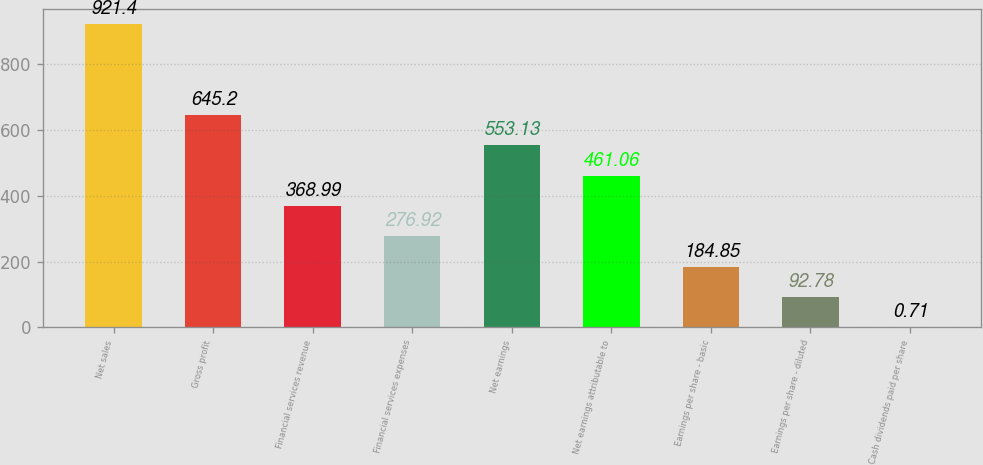Convert chart. <chart><loc_0><loc_0><loc_500><loc_500><bar_chart><fcel>Net sales<fcel>Gross profit<fcel>Financial services revenue<fcel>Financial services expenses<fcel>Net earnings<fcel>Net earnings attributable to<fcel>Earnings per share - basic<fcel>Earnings per share - diluted<fcel>Cash dividends paid per share<nl><fcel>921.4<fcel>645.2<fcel>368.99<fcel>276.92<fcel>553.13<fcel>461.06<fcel>184.85<fcel>92.78<fcel>0.71<nl></chart> 